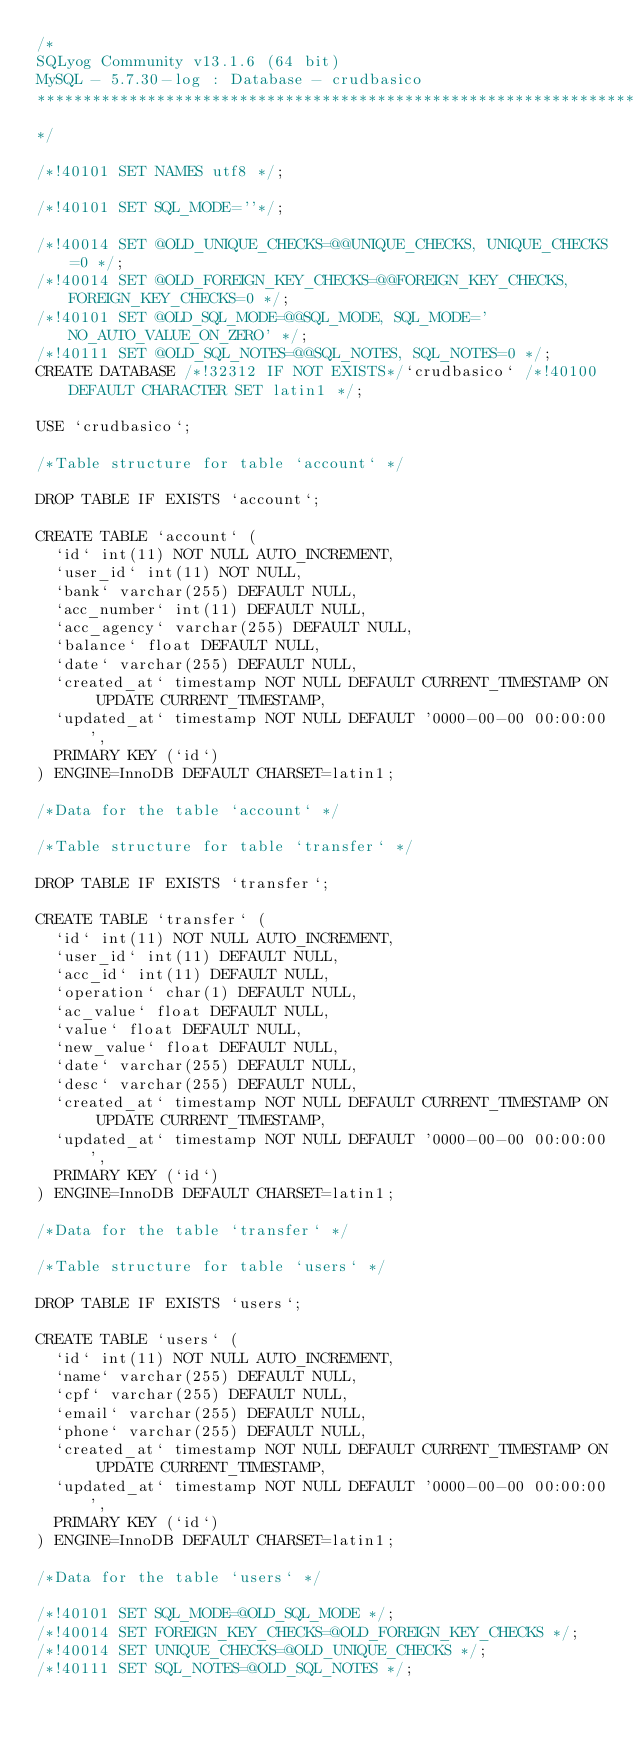Convert code to text. <code><loc_0><loc_0><loc_500><loc_500><_SQL_>/*
SQLyog Community v13.1.6 (64 bit)
MySQL - 5.7.30-log : Database - crudbasico
*********************************************************************
*/

/*!40101 SET NAMES utf8 */;

/*!40101 SET SQL_MODE=''*/;

/*!40014 SET @OLD_UNIQUE_CHECKS=@@UNIQUE_CHECKS, UNIQUE_CHECKS=0 */;
/*!40014 SET @OLD_FOREIGN_KEY_CHECKS=@@FOREIGN_KEY_CHECKS, FOREIGN_KEY_CHECKS=0 */;
/*!40101 SET @OLD_SQL_MODE=@@SQL_MODE, SQL_MODE='NO_AUTO_VALUE_ON_ZERO' */;
/*!40111 SET @OLD_SQL_NOTES=@@SQL_NOTES, SQL_NOTES=0 */;
CREATE DATABASE /*!32312 IF NOT EXISTS*/`crudbasico` /*!40100 DEFAULT CHARACTER SET latin1 */;

USE `crudbasico`;

/*Table structure for table `account` */

DROP TABLE IF EXISTS `account`;

CREATE TABLE `account` (
  `id` int(11) NOT NULL AUTO_INCREMENT,
  `user_id` int(11) NOT NULL,
  `bank` varchar(255) DEFAULT NULL,
  `acc_number` int(11) DEFAULT NULL,
  `acc_agency` varchar(255) DEFAULT NULL,
  `balance` float DEFAULT NULL,
  `date` varchar(255) DEFAULT NULL,
  `created_at` timestamp NOT NULL DEFAULT CURRENT_TIMESTAMP ON UPDATE CURRENT_TIMESTAMP,
  `updated_at` timestamp NOT NULL DEFAULT '0000-00-00 00:00:00',
  PRIMARY KEY (`id`)
) ENGINE=InnoDB DEFAULT CHARSET=latin1;

/*Data for the table `account` */

/*Table structure for table `transfer` */

DROP TABLE IF EXISTS `transfer`;

CREATE TABLE `transfer` (
  `id` int(11) NOT NULL AUTO_INCREMENT,
  `user_id` int(11) DEFAULT NULL,
  `acc_id` int(11) DEFAULT NULL,
  `operation` char(1) DEFAULT NULL,
  `ac_value` float DEFAULT NULL,
  `value` float DEFAULT NULL,
  `new_value` float DEFAULT NULL,
  `date` varchar(255) DEFAULT NULL,
  `desc` varchar(255) DEFAULT NULL,
  `created_at` timestamp NOT NULL DEFAULT CURRENT_TIMESTAMP ON UPDATE CURRENT_TIMESTAMP,
  `updated_at` timestamp NOT NULL DEFAULT '0000-00-00 00:00:00',
  PRIMARY KEY (`id`)
) ENGINE=InnoDB DEFAULT CHARSET=latin1;

/*Data for the table `transfer` */

/*Table structure for table `users` */

DROP TABLE IF EXISTS `users`;

CREATE TABLE `users` (
  `id` int(11) NOT NULL AUTO_INCREMENT,
  `name` varchar(255) DEFAULT NULL,
  `cpf` varchar(255) DEFAULT NULL,
  `email` varchar(255) DEFAULT NULL,
  `phone` varchar(255) DEFAULT NULL,
  `created_at` timestamp NOT NULL DEFAULT CURRENT_TIMESTAMP ON UPDATE CURRENT_TIMESTAMP,
  `updated_at` timestamp NOT NULL DEFAULT '0000-00-00 00:00:00',
  PRIMARY KEY (`id`)
) ENGINE=InnoDB DEFAULT CHARSET=latin1;

/*Data for the table `users` */

/*!40101 SET SQL_MODE=@OLD_SQL_MODE */;
/*!40014 SET FOREIGN_KEY_CHECKS=@OLD_FOREIGN_KEY_CHECKS */;
/*!40014 SET UNIQUE_CHECKS=@OLD_UNIQUE_CHECKS */;
/*!40111 SET SQL_NOTES=@OLD_SQL_NOTES */;
</code> 